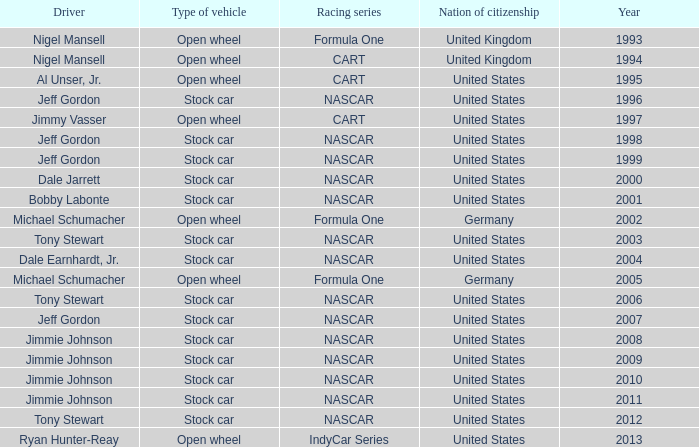What driver has a stock car vehicle with a year of 1999? Jeff Gordon. 